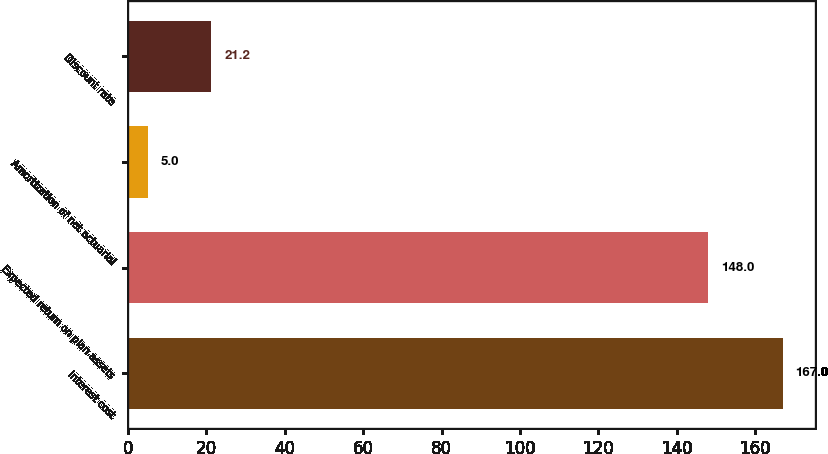<chart> <loc_0><loc_0><loc_500><loc_500><bar_chart><fcel>Interest cost<fcel>Expected return on plan assets<fcel>Amortization of net actuarial<fcel>Discount rate<nl><fcel>167<fcel>148<fcel>5<fcel>21.2<nl></chart> 